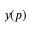Convert formula to latex. <formula><loc_0><loc_0><loc_500><loc_500>y ( p )</formula> 